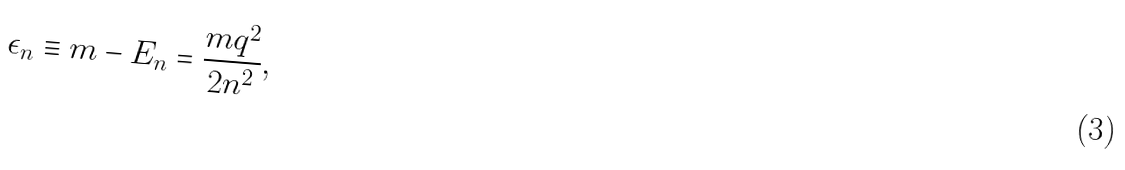Convert formula to latex. <formula><loc_0><loc_0><loc_500><loc_500>\epsilon _ { n } \equiv m - E _ { n } = \frac { m q ^ { 2 } } { 2 n ^ { 2 } } ,</formula> 